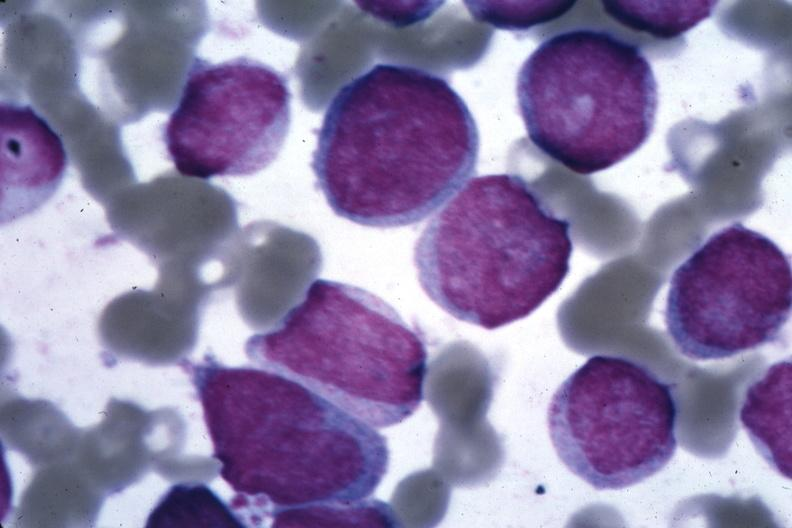s accessories diagnosed?
Answer the question using a single word or phrase. No 